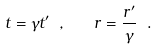Convert formula to latex. <formula><loc_0><loc_0><loc_500><loc_500>t = \gamma t ^ { \prime } \ , \quad r = \frac { r ^ { \prime } } { \gamma } \ .</formula> 